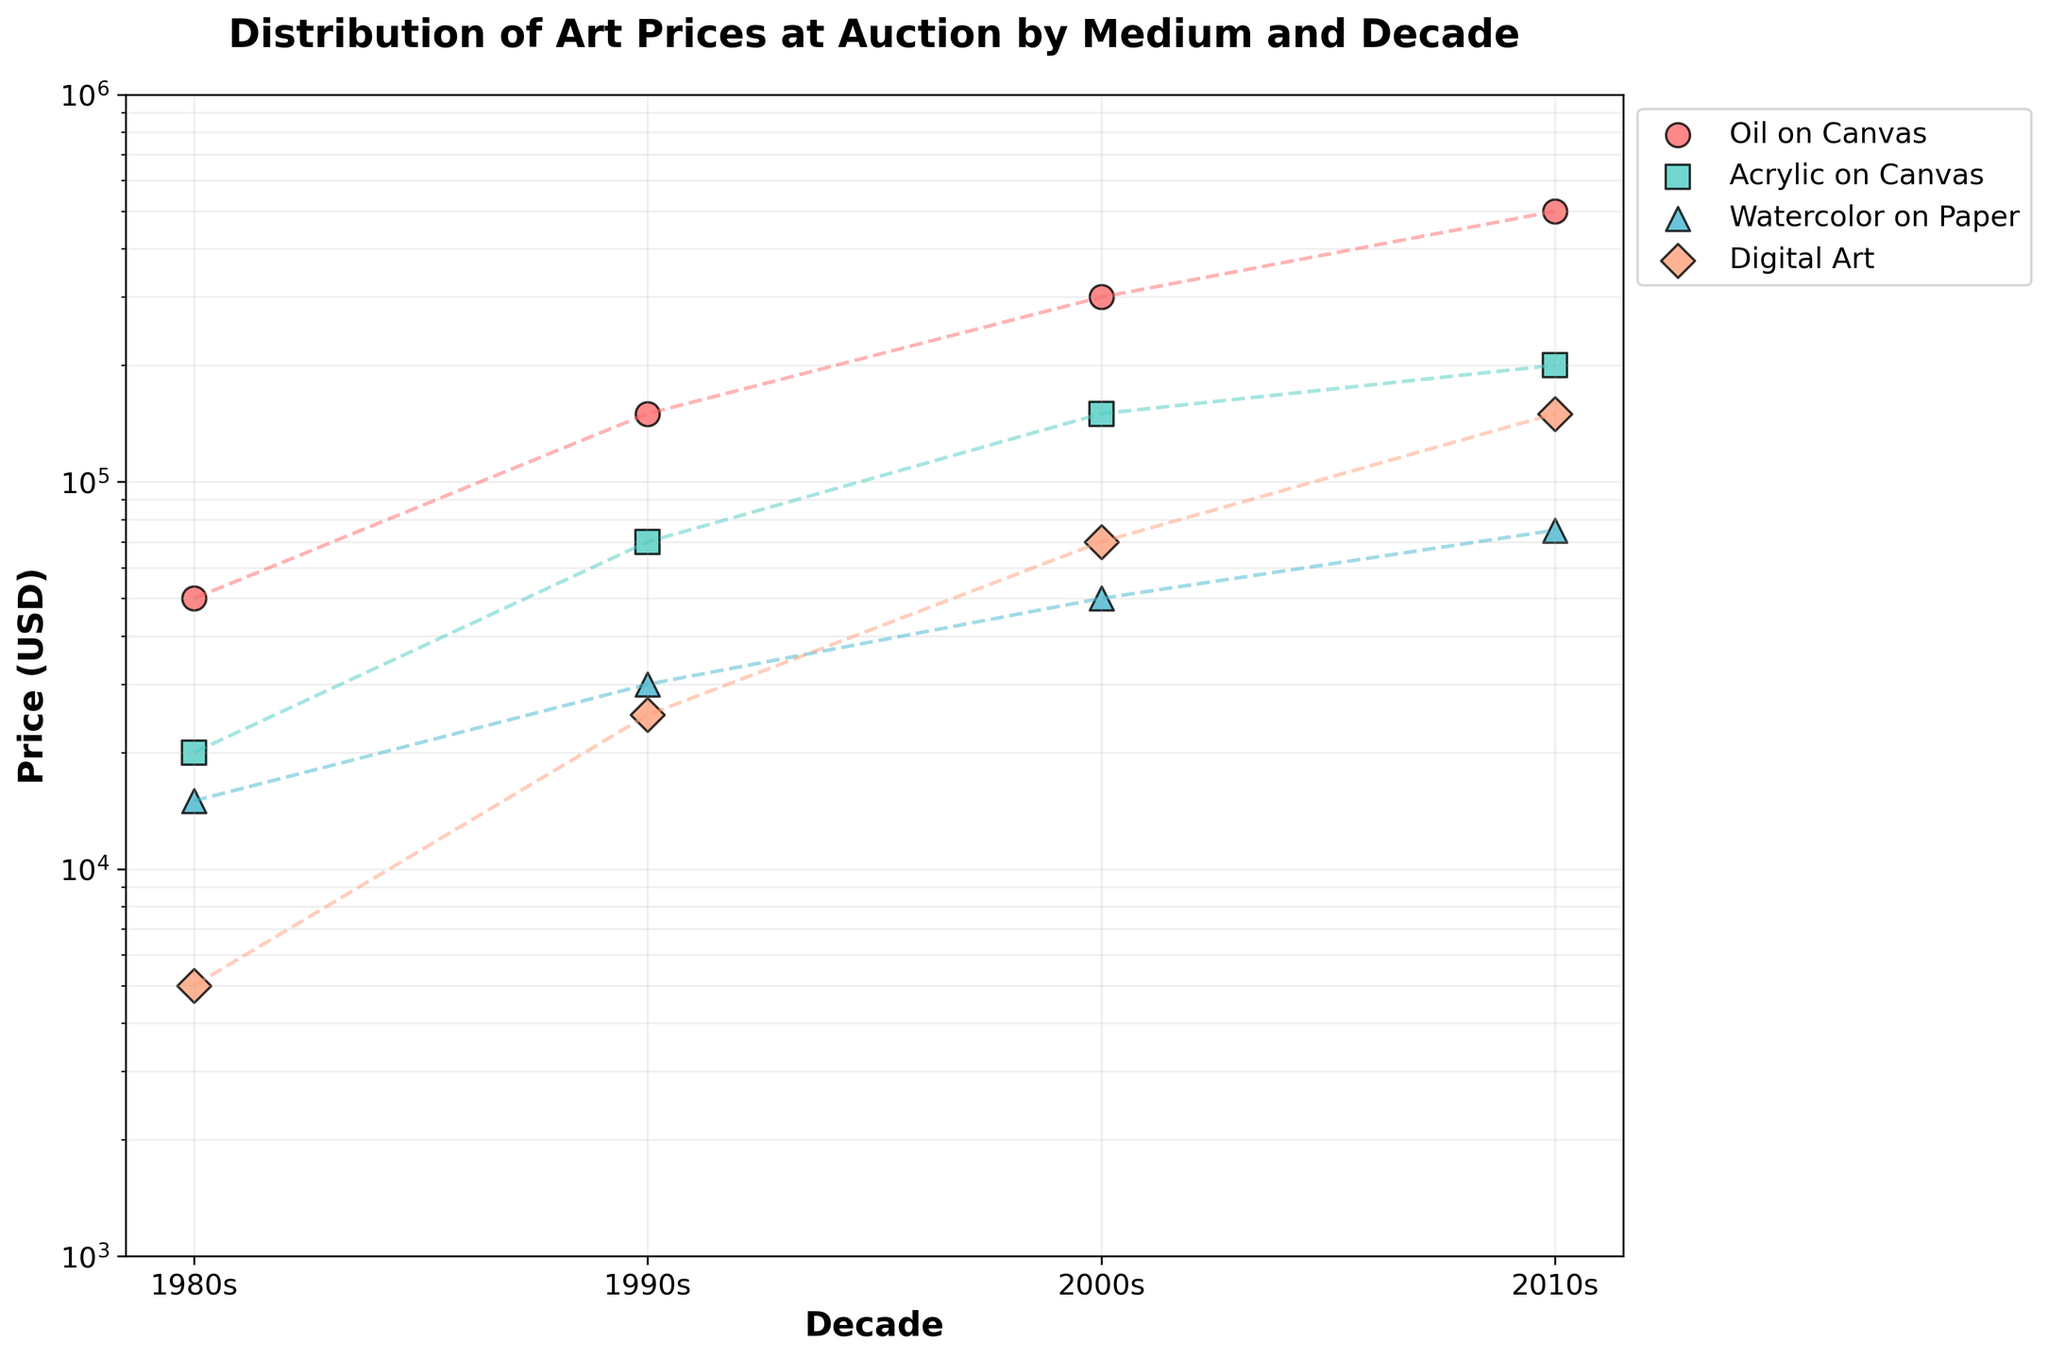How many different mediums are represented in the plot? There are four different markers/colors in the plot, each representing a different medium. This indicates that there are four mediums.
Answer: 4 mediums What is the title of the figure? The title is located at the top of the figure and clearly states the subject of the plot.
Answer: Distribution of Art Prices at Auction by Medium and Decade Which medium has the most significant increase in price from the 1980s to the 2010s? To find this, compare the prices of each medium between the 1980s and the 2010s. Oil on Canvas shows the most significant increase from $50,000 in the 1980s to $500,000 in the 2010s.
Answer: Oil on Canvas What is the range of prices for Acrylic on Canvas in the figure? The lowest price for Acrylic on Canvas is $20,000 in the 1980s, and the highest price is $200,000 in the 2010s. The range can be calculated by subtracting the lowest price from the highest price: $200,000 - $20,000 = $180,000.
Answer: $180,000 How do the prices of Digital Art change over the decades? For each decade, observe the prices of Digital Art: $5,000 in the 1980s, $25,000 in the 1990s, $70,000 in the 2000s, and $150,000 in the 2010s. The prices steadily increase each decade.
Answer: Steadily increase During which decade did Watercolor on Paper see its most significant price jump? Look at the prices for Watercolor on Paper over the decades: $15,000 in the 1980s, $30,000 in the 1990s, $50,000 in the 2000s, and $75,000 in the 2010s. The biggest jump occurs between the 1980s and the 1990s, where the price doubled from $15,000 to $30,000.
Answer: 1990s Which medium had the smallest change in price from the 1980s to the 2010s? To determine this, compare the price changes for each medium between the 1980s and 2010s. Watercolor on Paper increased by $60,000 ($15,000 to $75,000), the smallest increase compared to the other mediums.
Answer: Watercolor on Paper What is the y-axis label of the figure? The label for the y-axis can be found along the vertical axis on the left side of the plot, providing context for the data's scale.
Answer: Price (USD) What happens to the prices of Oil on Canvas from the 1990s to the 2000s? Look at the data points for Oil on Canvas in these decades: the price increases from $150,000 in the 1990s to $300,000 in the 2000s. This indicates a doubling in price.
Answer: They double Is there any medium that has a constant increase in price across all decades? Review the price changes across all decades for each medium. Digital Art shows a steady increase from $5,000 to $150,000 without any decrease or plateau.
Answer: Digital Art 